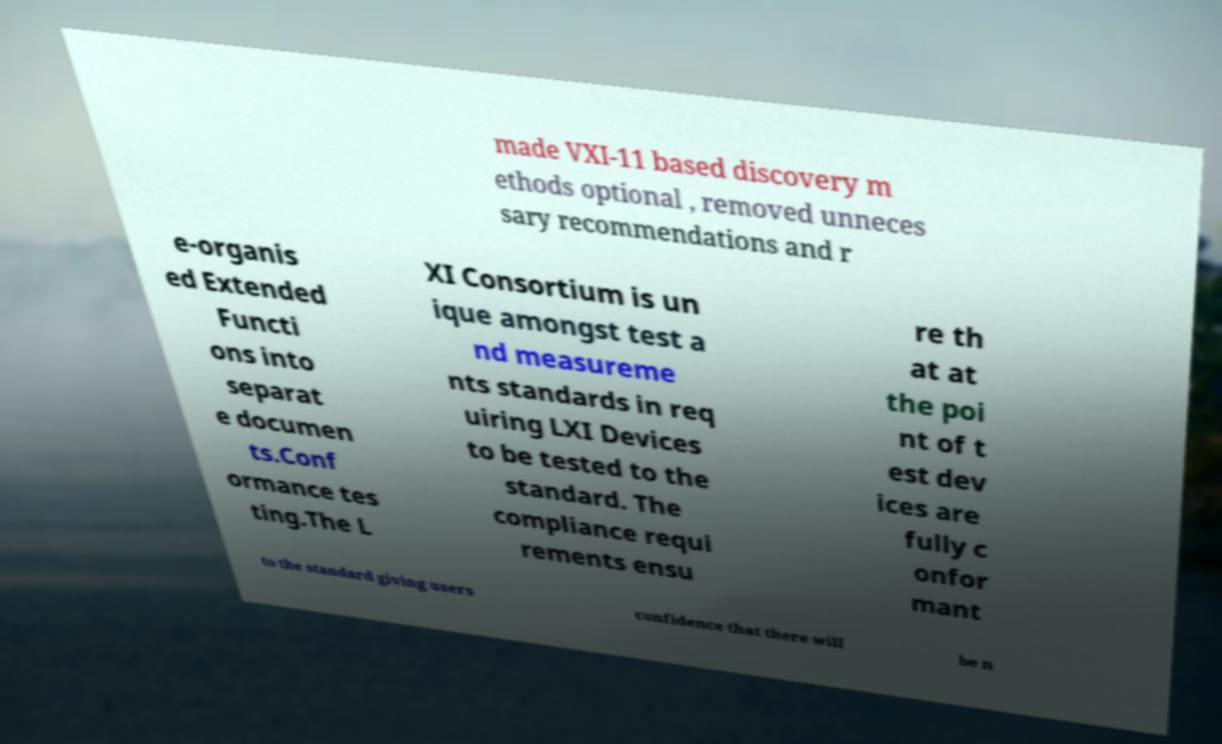Please read and relay the text visible in this image. What does it say? made VXI-11 based discovery m ethods optional , removed unneces sary recommendations and r e-organis ed Extended Functi ons into separat e documen ts.Conf ormance tes ting.The L XI Consortium is un ique amongst test a nd measureme nts standards in req uiring LXI Devices to be tested to the standard. The compliance requi rements ensu re th at at the poi nt of t est dev ices are fully c onfor mant to the standard giving users confidence that there will be n 